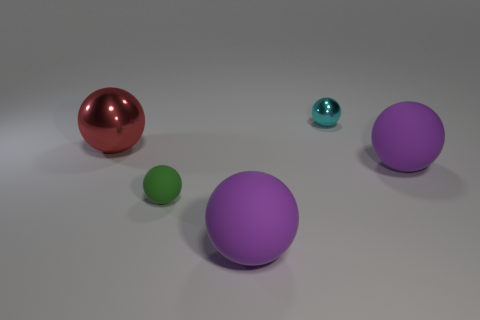There is a large thing that is both on the left side of the small cyan metal object and to the right of the small green matte thing; what is its color?
Provide a short and direct response. Purple. There is a thing on the left side of the green matte thing; is its size the same as the small cyan shiny object?
Your answer should be compact. No. There is a rubber ball that is in front of the small green rubber object; are there any green rubber spheres that are right of it?
Make the answer very short. No. What material is the green object?
Offer a terse response. Rubber. There is a small green object; are there any cyan shiny spheres to the right of it?
Give a very brief answer. Yes. There is a green object that is the same shape as the red metal thing; what size is it?
Keep it short and to the point. Small. Are there an equal number of small green rubber balls that are in front of the tiny rubber thing and matte objects that are behind the large red metallic ball?
Your answer should be compact. Yes. How many large green cylinders are there?
Ensure brevity in your answer.  0. Is the number of green rubber objects that are behind the red object greater than the number of tiny matte things?
Your answer should be very brief. No. What is the green sphere in front of the cyan metallic ball made of?
Give a very brief answer. Rubber. 